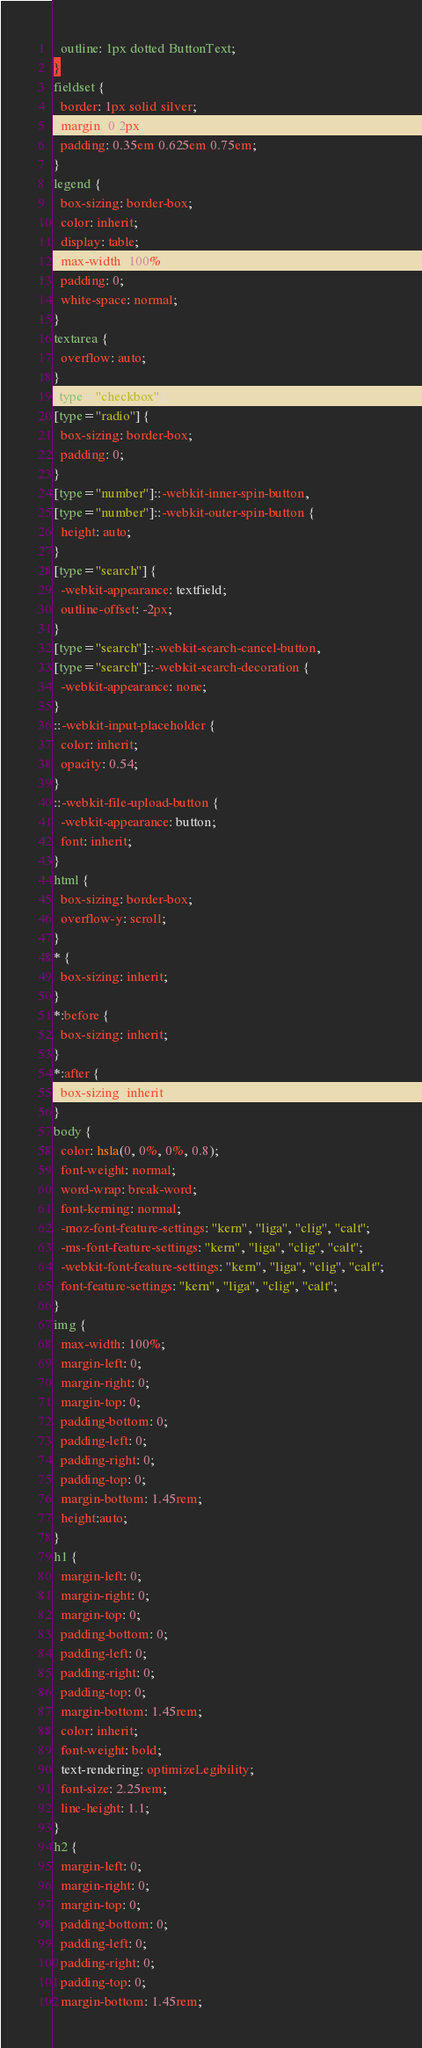<code> <loc_0><loc_0><loc_500><loc_500><_CSS_>  outline: 1px dotted ButtonText;
}
fieldset {
  border: 1px solid silver;
  margin: 0 2px;
  padding: 0.35em 0.625em 0.75em;
}
legend {
  box-sizing: border-box;
  color: inherit;
  display: table;
  max-width: 100%;
  padding: 0;
  white-space: normal;
}
textarea {
  overflow: auto;
}
[type="checkbox"],
[type="radio"] {
  box-sizing: border-box;
  padding: 0;
}
[type="number"]::-webkit-inner-spin-button,
[type="number"]::-webkit-outer-spin-button {
  height: auto;
}
[type="search"] {
  -webkit-appearance: textfield;
  outline-offset: -2px;
}
[type="search"]::-webkit-search-cancel-button,
[type="search"]::-webkit-search-decoration {
  -webkit-appearance: none;
}
::-webkit-input-placeholder {
  color: inherit;
  opacity: 0.54;
}
::-webkit-file-upload-button {
  -webkit-appearance: button;
  font: inherit;
}
html {
  box-sizing: border-box;
  overflow-y: scroll;
}
* {
  box-sizing: inherit;
}
*:before {
  box-sizing: inherit;
}
*:after {
  box-sizing: inherit;
}
body {
  color: hsla(0, 0%, 0%, 0.8);
  font-weight: normal;
  word-wrap: break-word;
  font-kerning: normal;
  -moz-font-feature-settings: "kern", "liga", "clig", "calt";
  -ms-font-feature-settings: "kern", "liga", "clig", "calt";
  -webkit-font-feature-settings: "kern", "liga", "clig", "calt";
  font-feature-settings: "kern", "liga", "clig", "calt";
}
img {
  max-width: 100%;
  margin-left: 0;
  margin-right: 0;
  margin-top: 0;
  padding-bottom: 0;
  padding-left: 0;
  padding-right: 0;
  padding-top: 0;
  margin-bottom: 1.45rem;
  height:auto;
}
h1 {
  margin-left: 0;
  margin-right: 0;
  margin-top: 0;
  padding-bottom: 0;
  padding-left: 0;
  padding-right: 0;
  padding-top: 0;
  margin-bottom: 1.45rem;
  color: inherit;
  font-weight: bold;
  text-rendering: optimizeLegibility;
  font-size: 2.25rem;
  line-height: 1.1;
}
h2 {
  margin-left: 0;
  margin-right: 0;
  margin-top: 0;
  padding-bottom: 0;
  padding-left: 0;
  padding-right: 0;
  padding-top: 0;
  margin-bottom: 1.45rem;</code> 